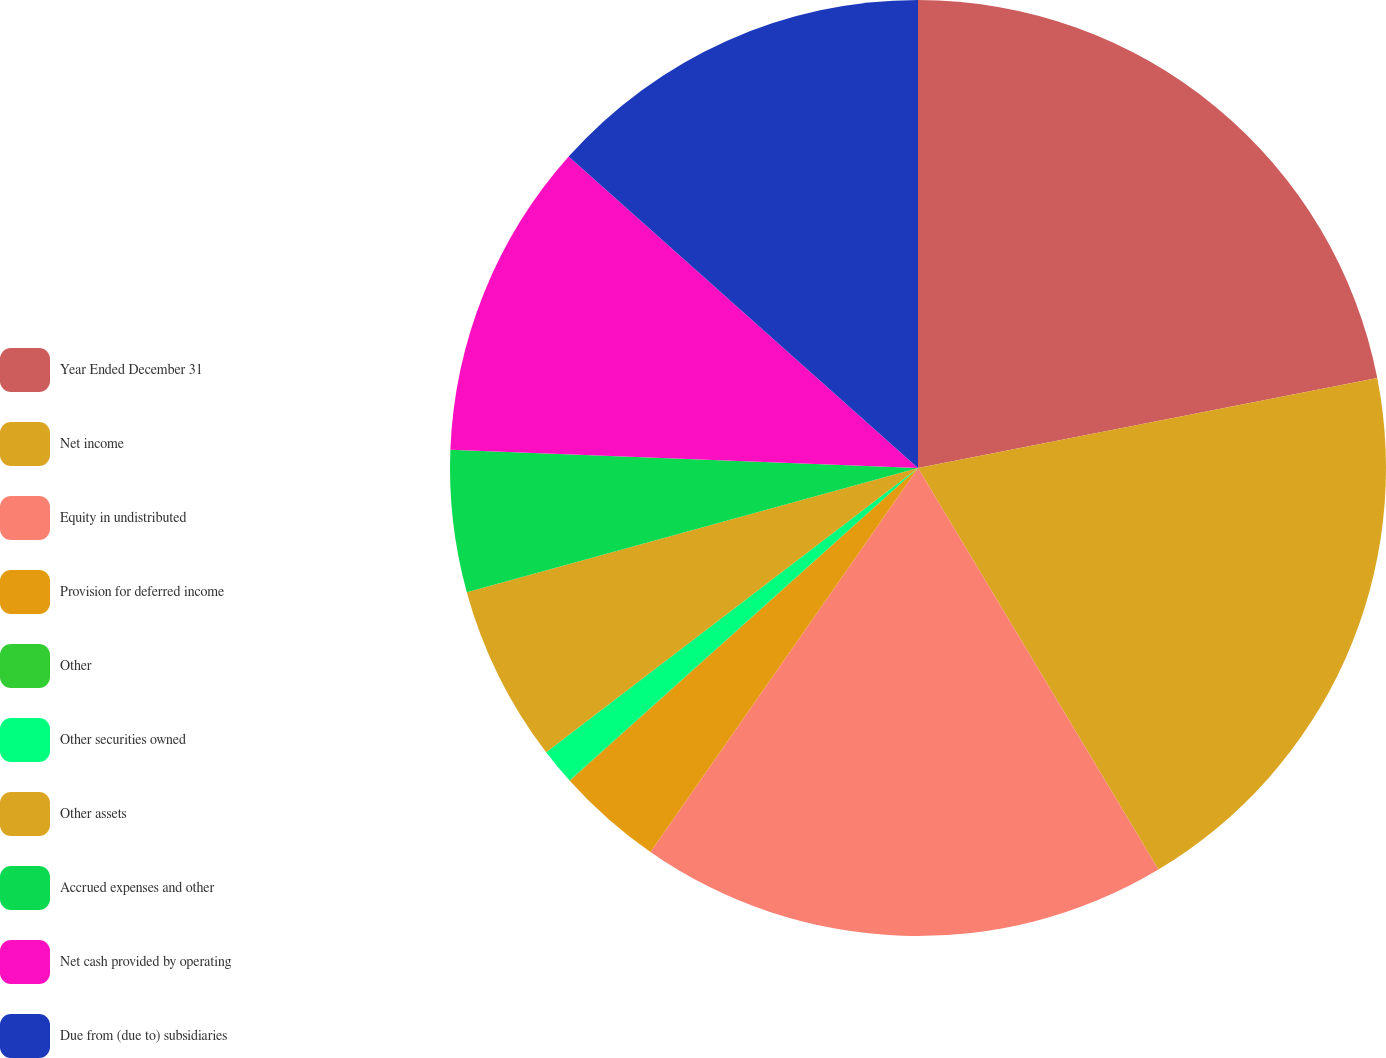Convert chart. <chart><loc_0><loc_0><loc_500><loc_500><pie_chart><fcel>Year Ended December 31<fcel>Net income<fcel>Equity in undistributed<fcel>Provision for deferred income<fcel>Other<fcel>Other securities owned<fcel>Other assets<fcel>Accrued expenses and other<fcel>Net cash provided by operating<fcel>Due from (due to) subsidiaries<nl><fcel>21.92%<fcel>19.49%<fcel>18.27%<fcel>3.67%<fcel>0.02%<fcel>1.24%<fcel>6.11%<fcel>4.89%<fcel>10.97%<fcel>13.41%<nl></chart> 